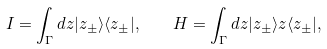<formula> <loc_0><loc_0><loc_500><loc_500>I = \int _ { \Gamma } d z | z _ { \pm } \rangle \langle z _ { \pm } | , \quad H = \int _ { \Gamma } d z | z _ { \pm } \rangle z \langle z _ { \pm } | ,</formula> 